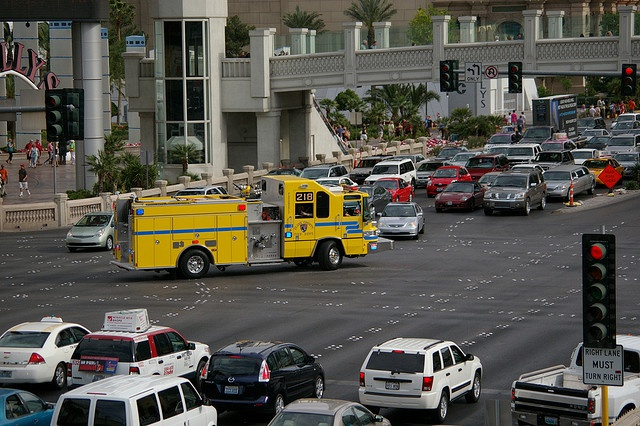Describe the objects in this image and their specific colors. I can see truck in black, orange, gray, and olive tones, car in black, gray, darkgray, and purple tones, people in black, gray, darkgray, and darkgreen tones, car in black, darkgray, lightgray, and gray tones, and car in black, gray, and darkgray tones in this image. 